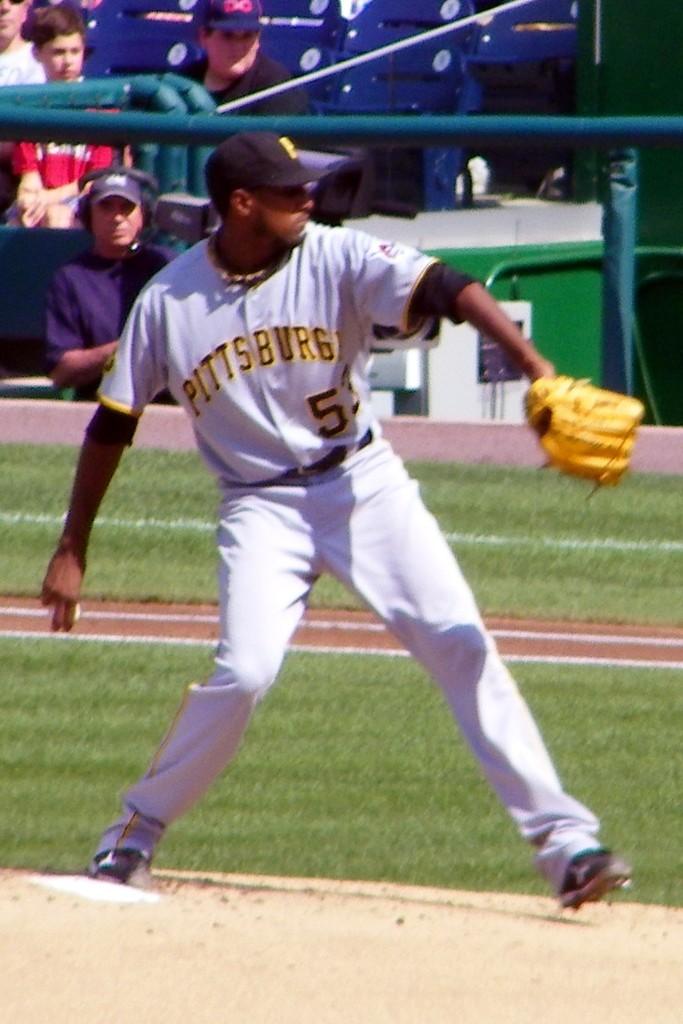What is one of the numbers on the jersey?
Your answer should be compact. 5. 